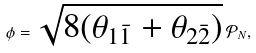<formula> <loc_0><loc_0><loc_500><loc_500>\phi = \sqrt { 8 ( \theta _ { 1 \bar { 1 } } + \theta _ { 2 \bar { 2 } } ) } \, \mathcal { P } _ { N } ,</formula> 